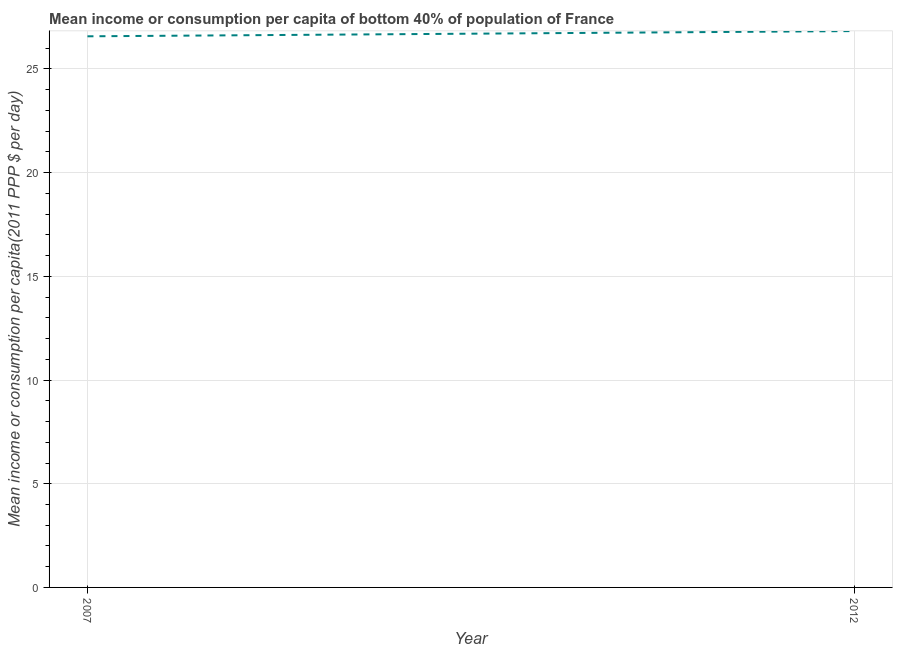What is the mean income or consumption in 2012?
Offer a terse response. 26.83. Across all years, what is the maximum mean income or consumption?
Your response must be concise. 26.83. Across all years, what is the minimum mean income or consumption?
Offer a terse response. 26.58. In which year was the mean income or consumption minimum?
Provide a succinct answer. 2007. What is the sum of the mean income or consumption?
Ensure brevity in your answer.  53.4. What is the difference between the mean income or consumption in 2007 and 2012?
Your answer should be compact. -0.25. What is the average mean income or consumption per year?
Keep it short and to the point. 26.7. What is the median mean income or consumption?
Your response must be concise. 26.7. Do a majority of the years between 2012 and 2007 (inclusive) have mean income or consumption greater than 25 $?
Your response must be concise. No. What is the ratio of the mean income or consumption in 2007 to that in 2012?
Your answer should be very brief. 0.99. Is the mean income or consumption in 2007 less than that in 2012?
Keep it short and to the point. Yes. How many lines are there?
Your answer should be very brief. 1. What is the difference between two consecutive major ticks on the Y-axis?
Ensure brevity in your answer.  5. Are the values on the major ticks of Y-axis written in scientific E-notation?
Provide a short and direct response. No. Does the graph contain any zero values?
Offer a very short reply. No. Does the graph contain grids?
Provide a short and direct response. Yes. What is the title of the graph?
Ensure brevity in your answer.  Mean income or consumption per capita of bottom 40% of population of France. What is the label or title of the Y-axis?
Your answer should be compact. Mean income or consumption per capita(2011 PPP $ per day). What is the Mean income or consumption per capita(2011 PPP $ per day) in 2007?
Offer a terse response. 26.58. What is the Mean income or consumption per capita(2011 PPP $ per day) in 2012?
Give a very brief answer. 26.83. What is the difference between the Mean income or consumption per capita(2011 PPP $ per day) in 2007 and 2012?
Your answer should be very brief. -0.25. What is the ratio of the Mean income or consumption per capita(2011 PPP $ per day) in 2007 to that in 2012?
Your answer should be very brief. 0.99. 